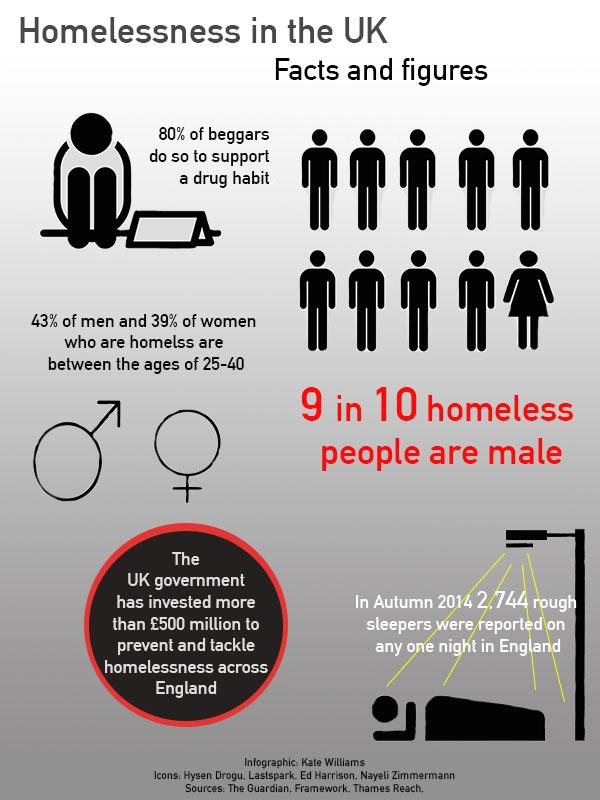List a handful of essential elements in this visual. According to a study, the predominant age of 39% of homeless women is between 25 and 40 years old. According to estimates, 90% of homeless individuals are male. The predominant age of 43% of homeless men is between 25 and 40 years old. According to a recent survey, only 20% of beggars do not beg to support a drug habit. 